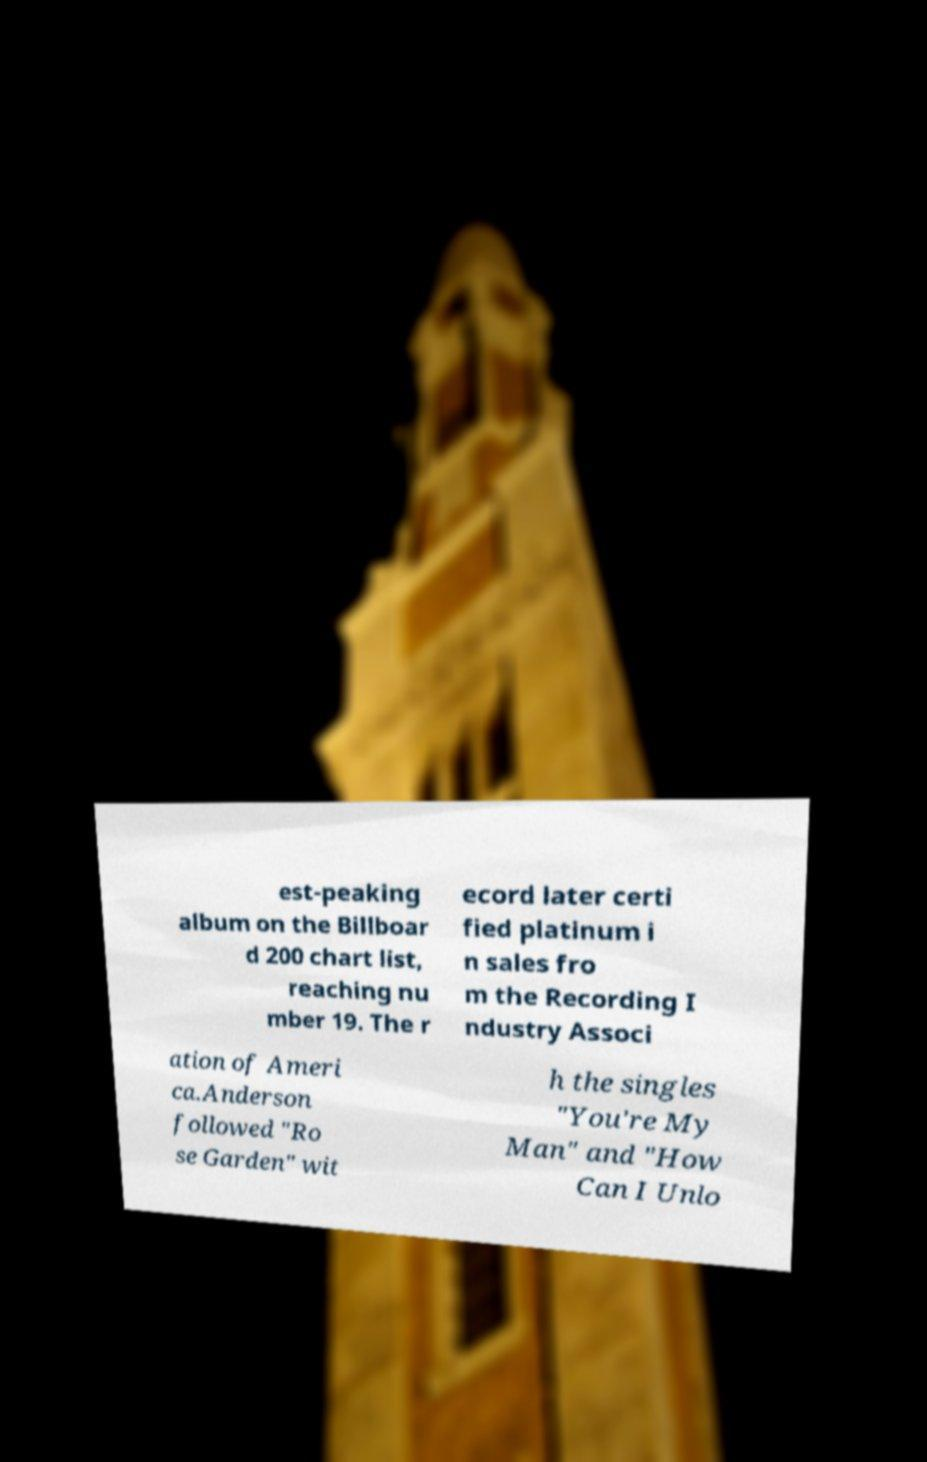There's text embedded in this image that I need extracted. Can you transcribe it verbatim? est-peaking album on the Billboar d 200 chart list, reaching nu mber 19. The r ecord later certi fied platinum i n sales fro m the Recording I ndustry Associ ation of Ameri ca.Anderson followed "Ro se Garden" wit h the singles "You're My Man" and "How Can I Unlo 